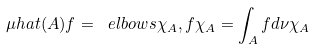Convert formula to latex. <formula><loc_0><loc_0><loc_500><loc_500>\mu h a t ( A ) f = \ e l b o w s { \chi _ { A } , f } \chi _ { A } = \int _ { A } f d \nu \chi _ { A }</formula> 